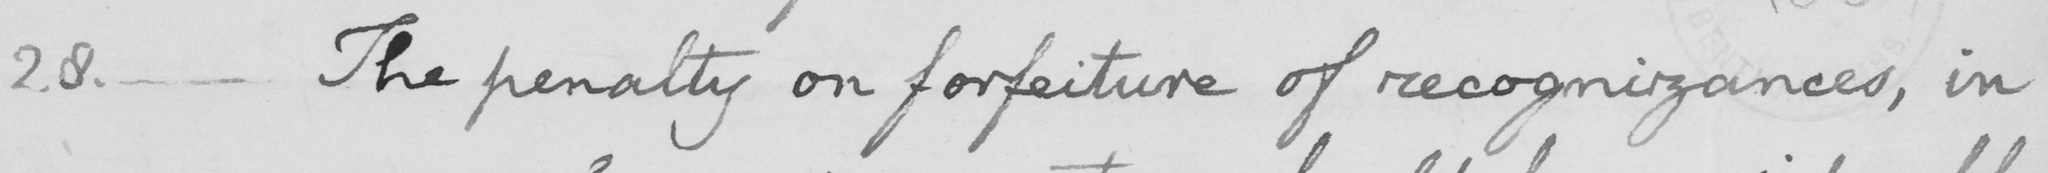Can you tell me what this handwritten text says? 28. _ The penalty on forfeiture of recognizances, in 